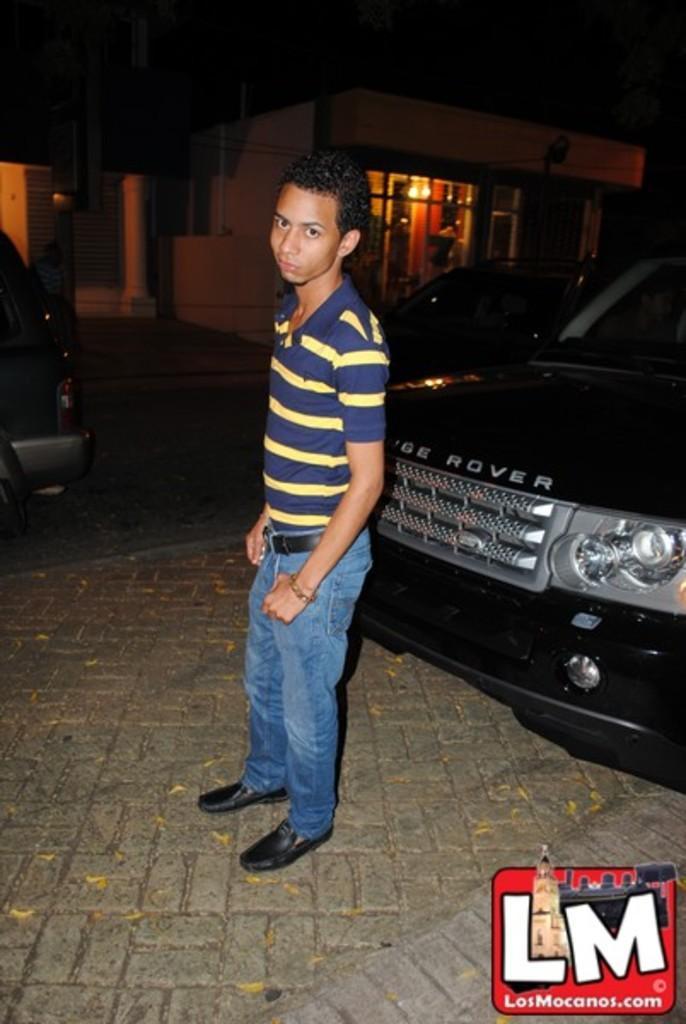Can you describe this image briefly? In this image I can see a person wearing blue and yellow colored dress is standing on the ground. I can see a car which is black in color behind him. In the background I can see few vehicles, a building , few lights and the sky. 